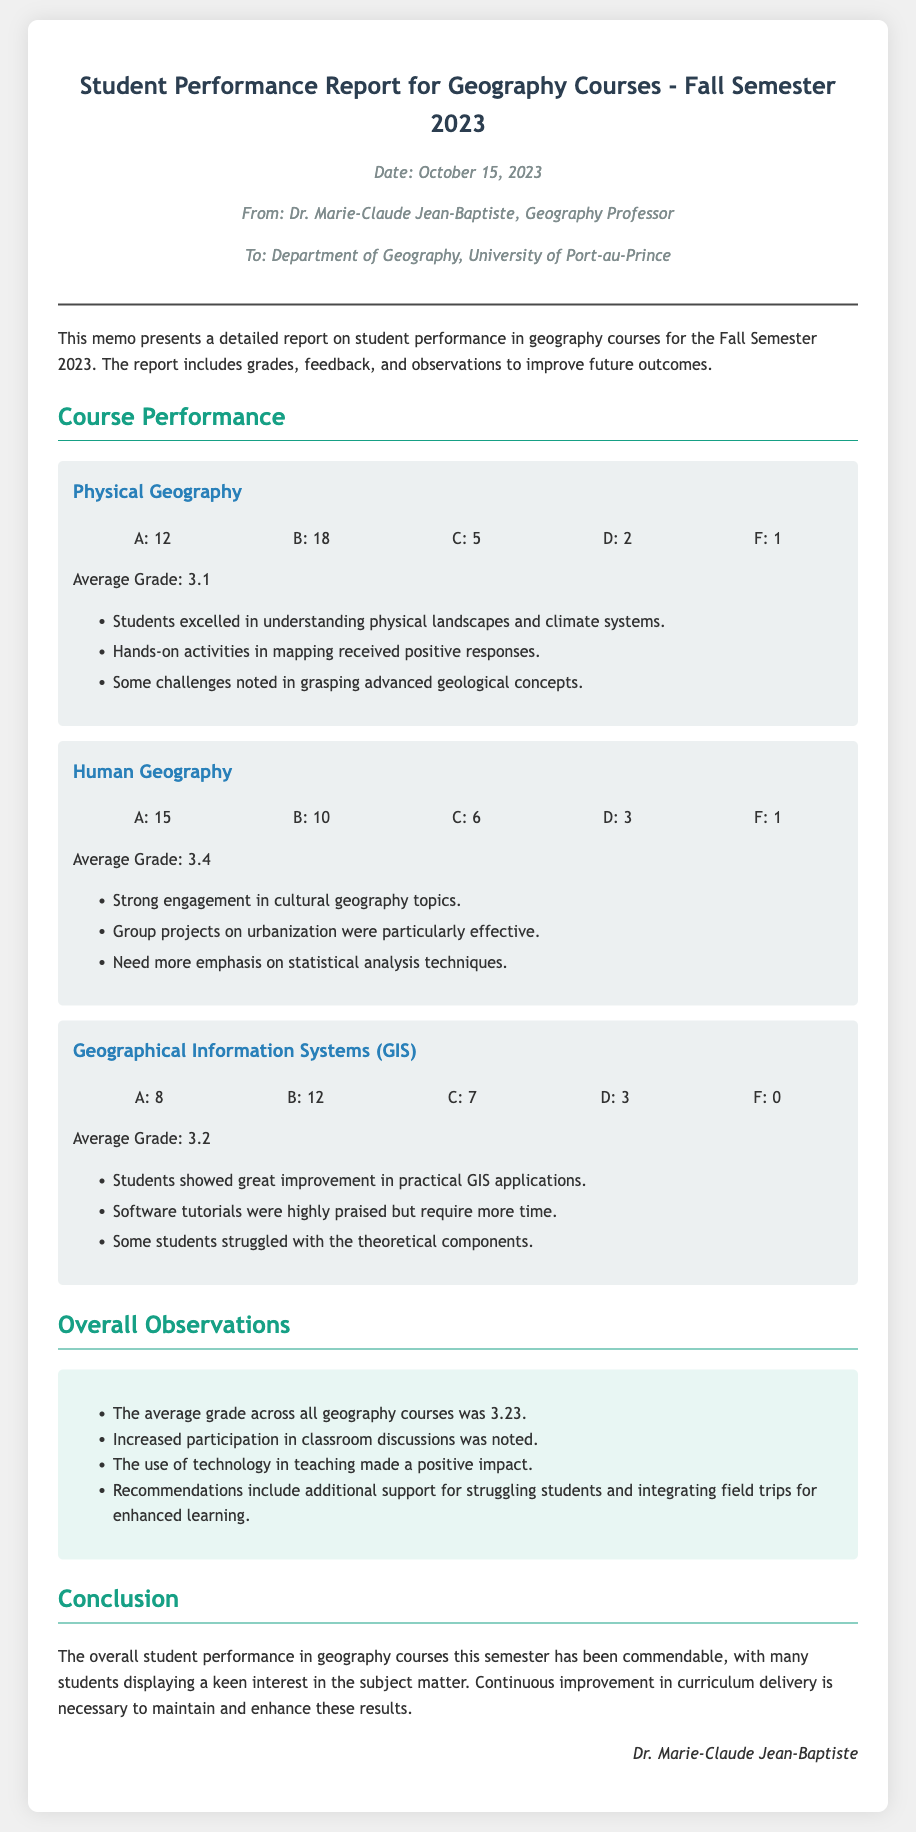What is the date of the report? The date of the report is mentioned at the beginning of the document as October 15, 2023.
Answer: October 15, 2023 Who is the author of the memo? The author of the memo is Dr. Marie-Claude Jean-Baptiste, as noted in the header section.
Answer: Dr. Marie-Claude Jean-Baptiste How many students received an 'A' in Human Geography? The number of students who received an 'A' in Human Geography is stated in the course section as 15.
Answer: 15 What is the average grade for Physical Geography? The average grade for Physical Geography is provided in the course section as 3.1.
Answer: 3.1 What was noted as a challenge in GIS course performance? A challenge noted in the GIS course performance is that some students struggled with the theoretical components, as indicated in the feedback.
Answer: Theoretical components How many geography courses are discussed in the report? The report discusses three geography courses, which are Physical Geography, Human Geography, and GIS.
Answer: Three What overall recommendation is made in the memo? The overall recommendation made in the memo includes additional support for struggling students, as found in the overall observations section.
Answer: Additional support for struggling students What percentage of students received a grade of 'F' in Physical Geography? The number of students receiving an 'F' in Physical Geography is 1, and with a total of 38 students, the percentage calculation reveals the proportion of students.
Answer: Approximately 2.63% What is the memo's primary purpose? The primary purpose of the memo is to present a detailed report on student performance in geography courses for the Fall Semester 2023.
Answer: Student performance report 